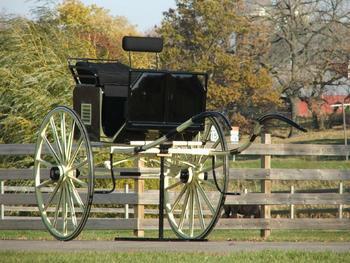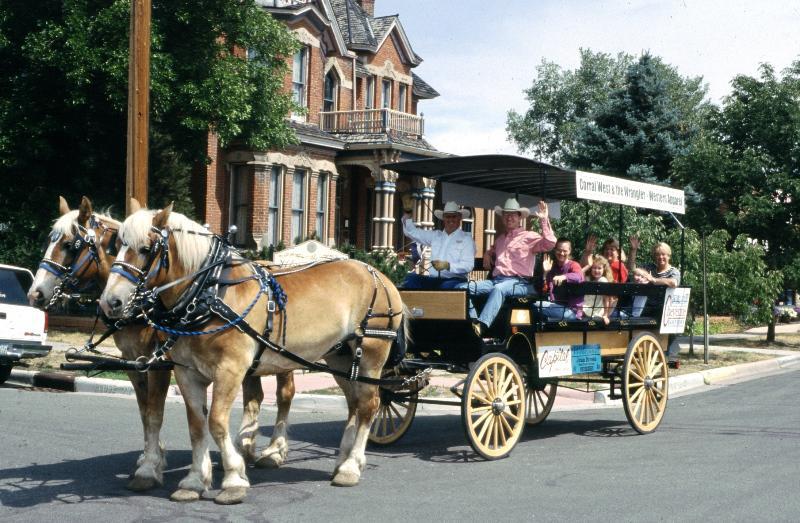The first image is the image on the left, the second image is the image on the right. Considering the images on both sides, is "There is a carriage without any horses attached to it." valid? Answer yes or no. Yes. The first image is the image on the left, the second image is the image on the right. For the images displayed, is the sentence "There are multiple people being pulled in a carriage in the street by two horses in the right image." factually correct? Answer yes or no. Yes. 